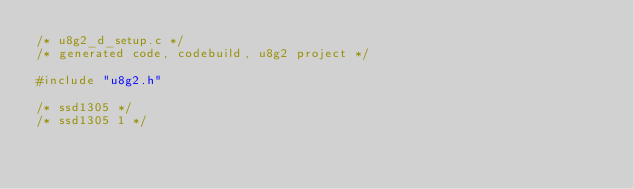Convert code to text. <code><loc_0><loc_0><loc_500><loc_500><_C_>/* u8g2_d_setup.c */
/* generated code, codebuild, u8g2 project */

#include "u8g2.h"

/* ssd1305 */
/* ssd1305 1 */</code> 